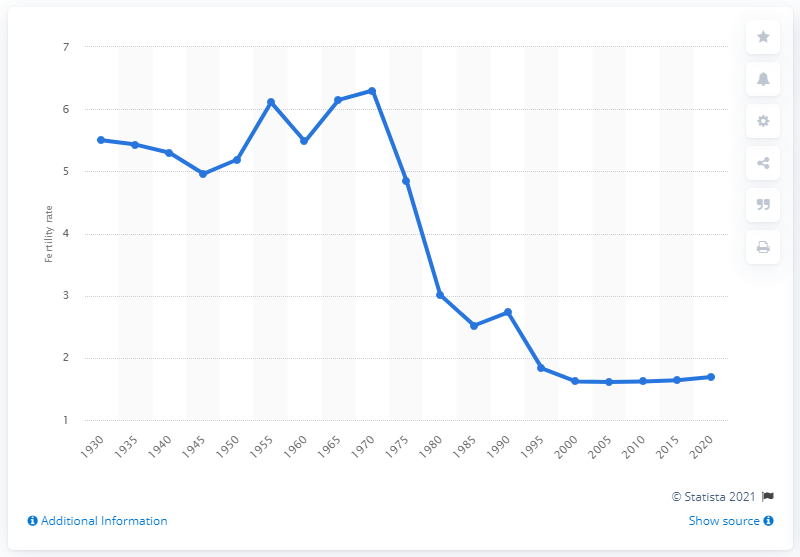Give some essential details in this illustration. The highest level of China's fertility rate was reached in 1970. 